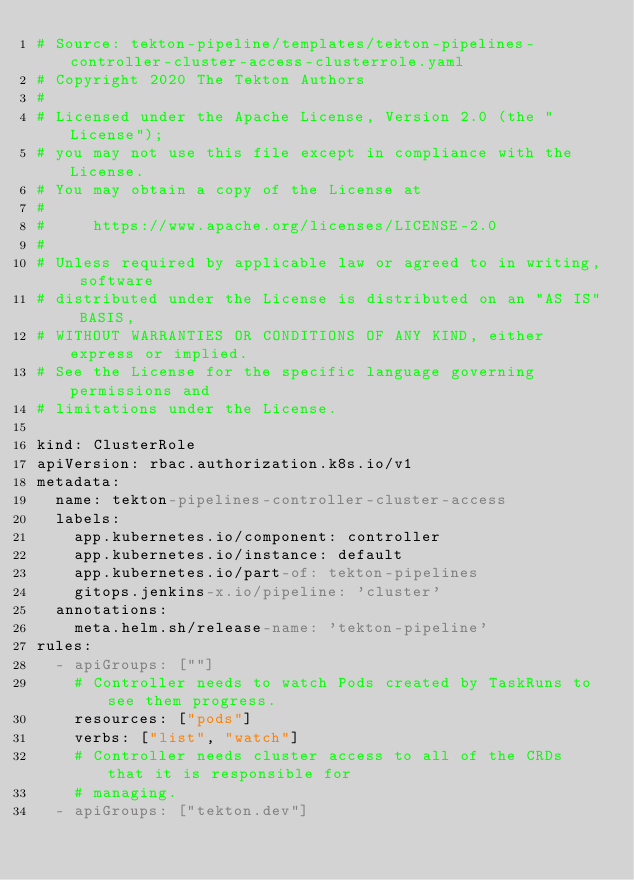Convert code to text. <code><loc_0><loc_0><loc_500><loc_500><_YAML_># Source: tekton-pipeline/templates/tekton-pipelines-controller-cluster-access-clusterrole.yaml
# Copyright 2020 The Tekton Authors
#
# Licensed under the Apache License, Version 2.0 (the "License");
# you may not use this file except in compliance with the License.
# You may obtain a copy of the License at
#
#     https://www.apache.org/licenses/LICENSE-2.0
#
# Unless required by applicable law or agreed to in writing, software
# distributed under the License is distributed on an "AS IS" BASIS,
# WITHOUT WARRANTIES OR CONDITIONS OF ANY KIND, either express or implied.
# See the License for the specific language governing permissions and
# limitations under the License.

kind: ClusterRole
apiVersion: rbac.authorization.k8s.io/v1
metadata:
  name: tekton-pipelines-controller-cluster-access
  labels:
    app.kubernetes.io/component: controller
    app.kubernetes.io/instance: default
    app.kubernetes.io/part-of: tekton-pipelines
    gitops.jenkins-x.io/pipeline: 'cluster'
  annotations:
    meta.helm.sh/release-name: 'tekton-pipeline'
rules:
  - apiGroups: [""]
    # Controller needs to watch Pods created by TaskRuns to see them progress.
    resources: ["pods"]
    verbs: ["list", "watch"]
    # Controller needs cluster access to all of the CRDs that it is responsible for
    # managing.
  - apiGroups: ["tekton.dev"]</code> 